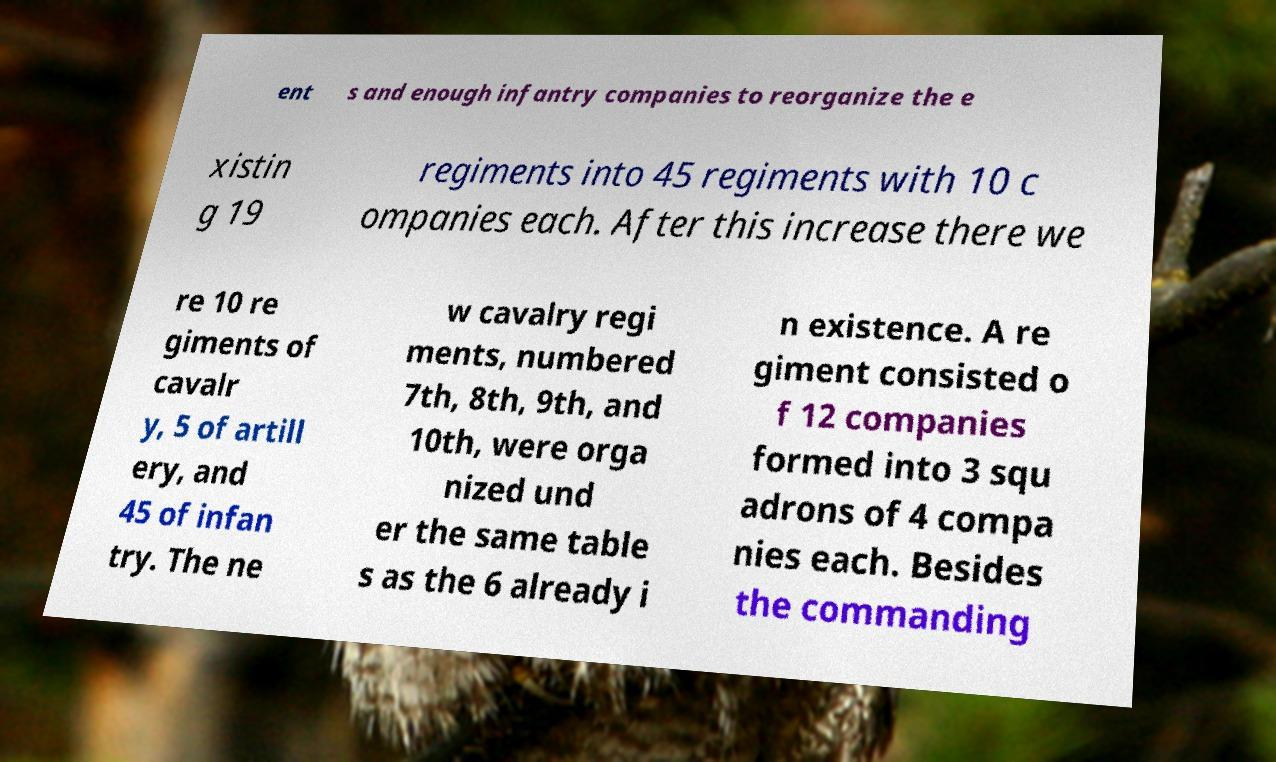Please read and relay the text visible in this image. What does it say? ent s and enough infantry companies to reorganize the e xistin g 19 regiments into 45 regiments with 10 c ompanies each. After this increase there we re 10 re giments of cavalr y, 5 of artill ery, and 45 of infan try. The ne w cavalry regi ments, numbered 7th, 8th, 9th, and 10th, were orga nized und er the same table s as the 6 already i n existence. A re giment consisted o f 12 companies formed into 3 squ adrons of 4 compa nies each. Besides the commanding 